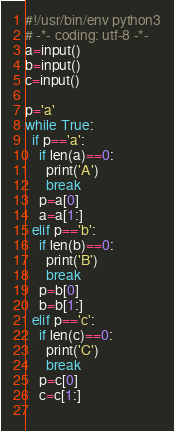<code> <loc_0><loc_0><loc_500><loc_500><_Python_>#!/usr/bin/env python3
# -*- coding: utf-8 -*-
a=input()
b=input()
c=input()

p='a'
while True:
  if p=='a':
    if len(a)==0:
      print('A')
      break
    p=a[0]
    a=a[1:]
  elif p=='b':
    if len(b)==0:
      print('B')
      break
    p=b[0]
    b=b[1:]
  elif p=='c':
    if len(c)==0:
      print('C')
      break
    p=c[0]
    c=c[1:]
  
</code> 